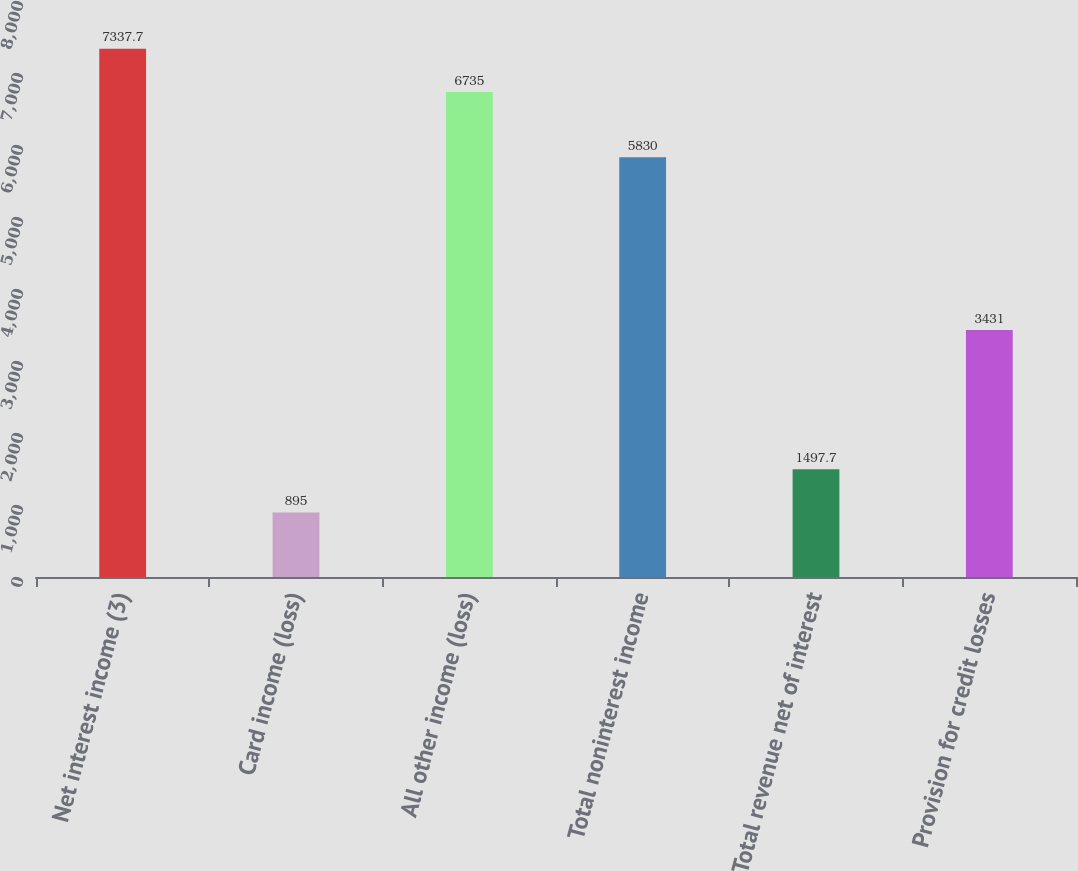Convert chart. <chart><loc_0><loc_0><loc_500><loc_500><bar_chart><fcel>Net interest income (3)<fcel>Card income (loss)<fcel>All other income (loss)<fcel>Total noninterest income<fcel>Total revenue net of interest<fcel>Provision for credit losses<nl><fcel>7337.7<fcel>895<fcel>6735<fcel>5830<fcel>1497.7<fcel>3431<nl></chart> 